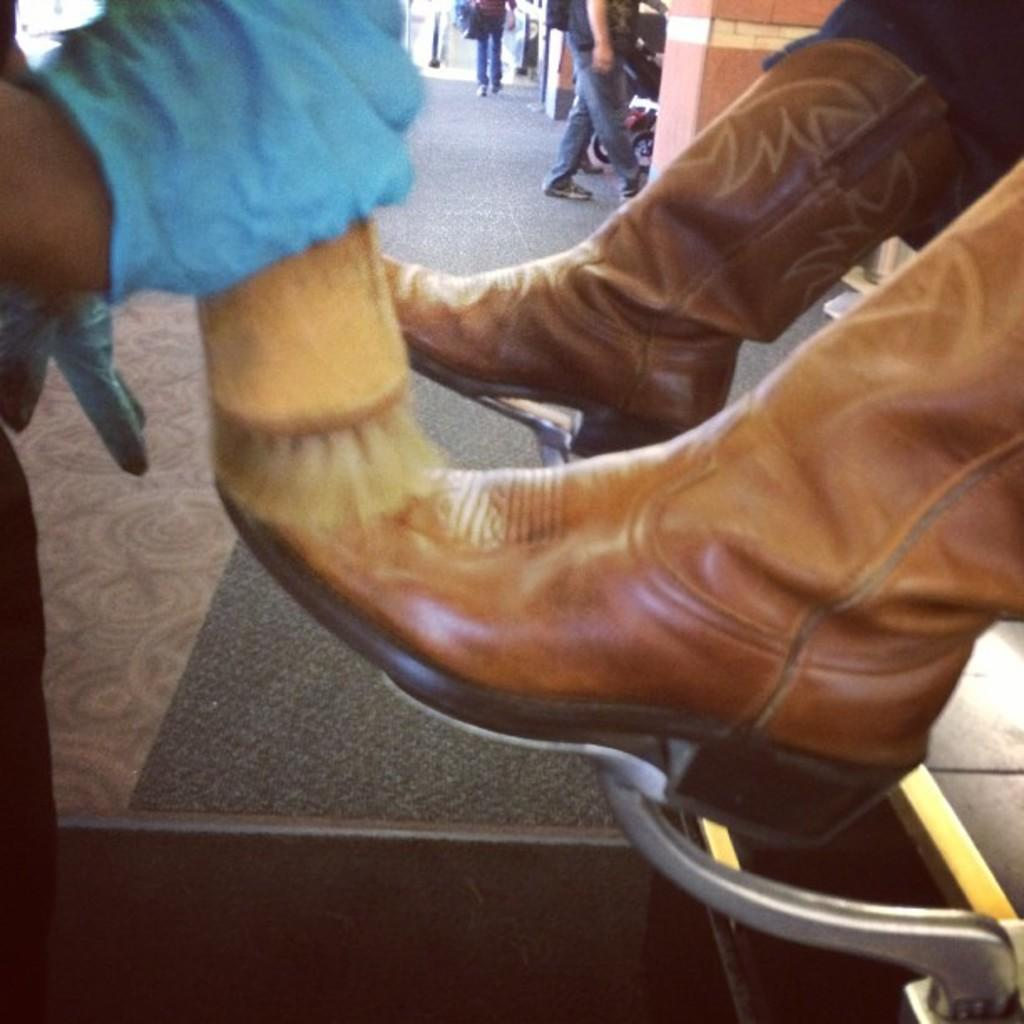What type of flooring is visible in the image? There is a mat and tiles in the image. What is the background of the image? There is a wall in the image. Are there any people in the image? Yes, there are people in the image. What can be seen on the feet of one of the people in the image? A person is wearing brown shoes in the image. What type of record can be heard playing in the background of the image? There is no record playing in the background of the image; it is a still image. Can you describe the hand gestures of the people in the image? The provided facts do not mention any hand gestures of the people in the image. --- 